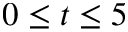<formula> <loc_0><loc_0><loc_500><loc_500>0 \leq t \leq 5</formula> 